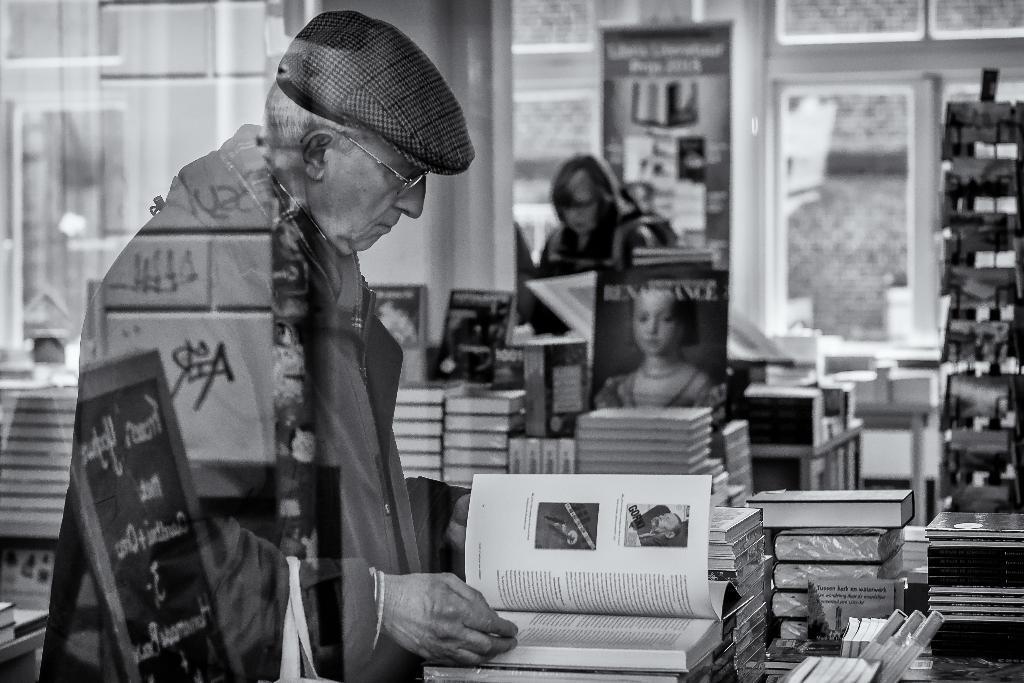Can you describe this image briefly? This is a black and white image. I can see an old man standing and reading the book. He wore a hat, spectacles and jerkin. I think this picture was taken in the bookstore. These are the books arranged in an order. Here is a woman standing. This looks like a glass door. 